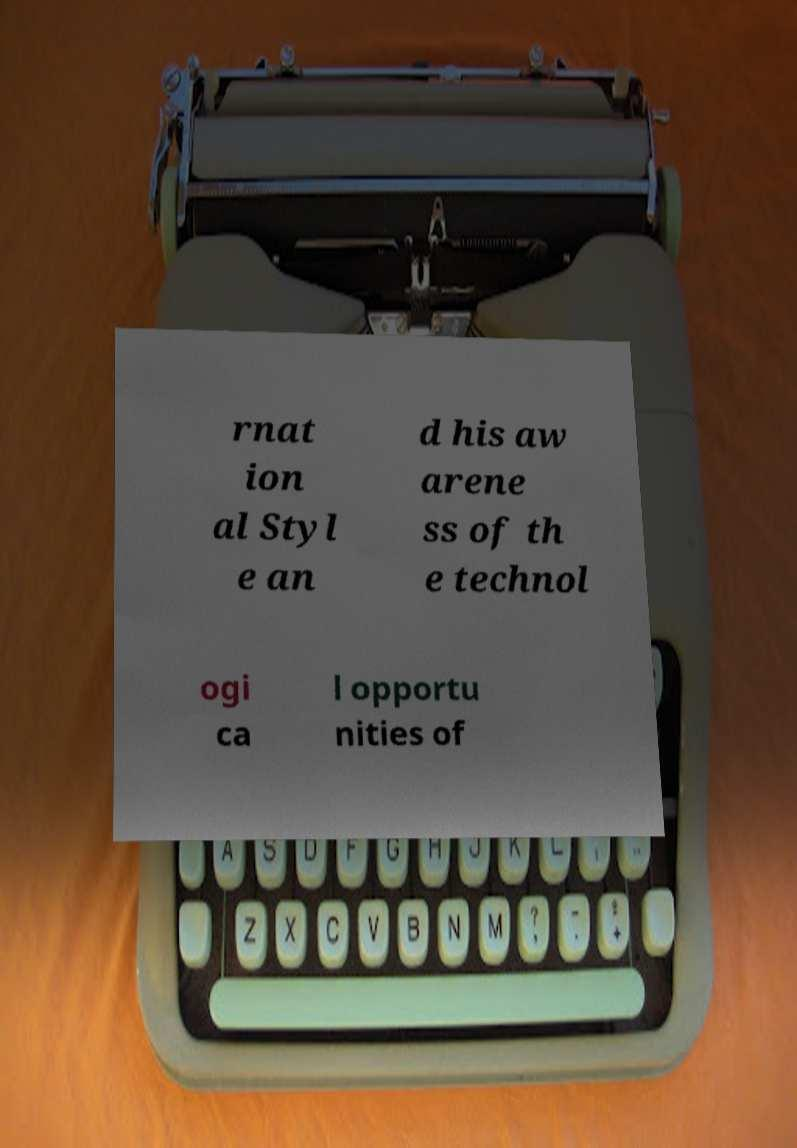Can you accurately transcribe the text from the provided image for me? rnat ion al Styl e an d his aw arene ss of th e technol ogi ca l opportu nities of 